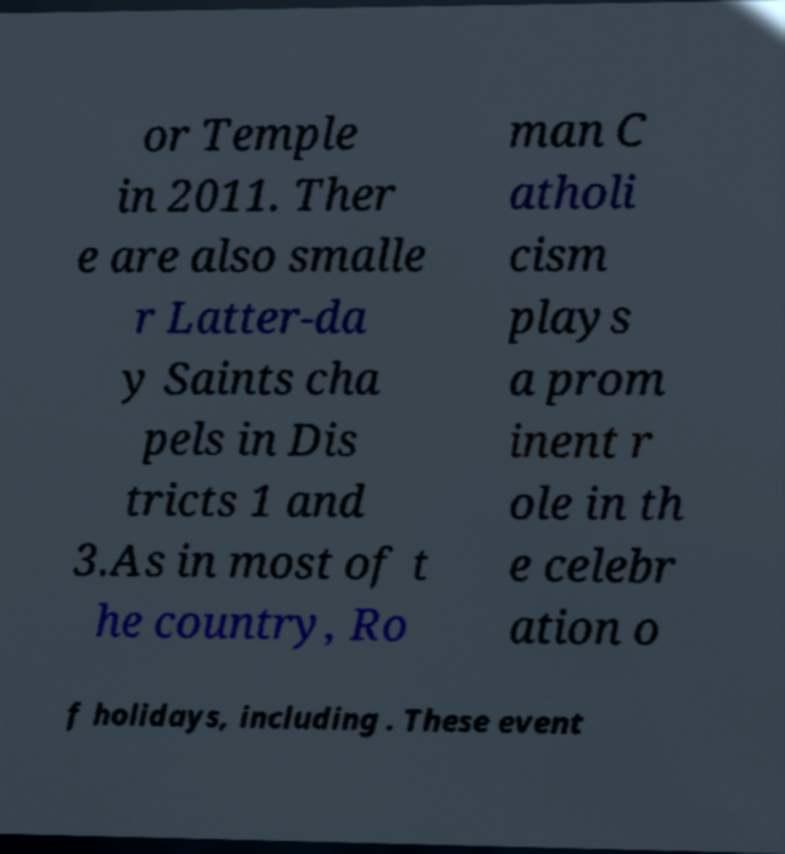Could you extract and type out the text from this image? or Temple in 2011. Ther e are also smalle r Latter-da y Saints cha pels in Dis tricts 1 and 3.As in most of t he country, Ro man C atholi cism plays a prom inent r ole in th e celebr ation o f holidays, including . These event 